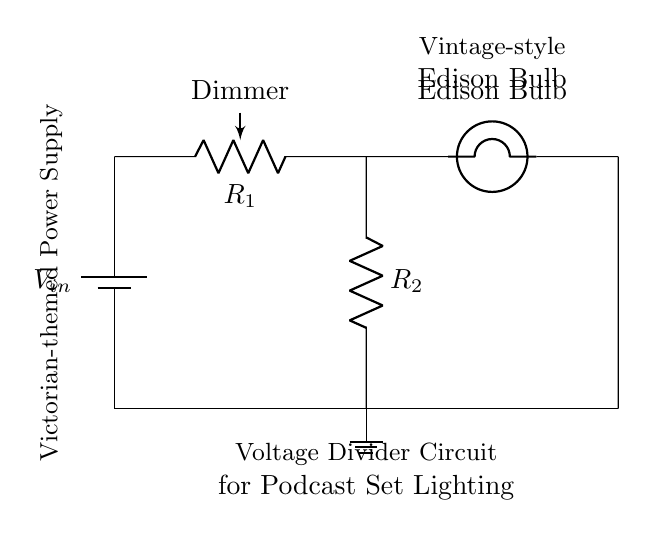What is the input voltage of the circuit? The circuit diagram shows a battery labeled as V_in, which indicates the input voltage. Therefore, we can refer to this label as the input voltage of the circuit.
Answer: V_in What types of components are used in this circuit? The circuit contains a battery, a potentiometer, a resistor, and a bulb. These components are standard in electronic circuits and can be identified directly from the labels in the diagram.
Answer: Battery, potentiometer, resistor, bulb How many resistors are present in the circuit? The circuit displays a potentiometer labeled R_1 and a separate resistor labeled R_2. Counting both components indicates that there are two resistors in total.
Answer: 2 What is the purpose of the potentiometer in this circuit? The potentiometer acts as a dimmer, allowing users to adjust the resistance, and thus the dimness of the Edison bulb's light output. This function is crucial for controlling the brightness of the vintage-style bulbs in the circuit.
Answer: Dimming What happens to the brightness of the bulb when the resistance in the circuit is increased? Increasing the resistance, particularly with the potentiometer, results in a decrease in current flowing through the bulb. Since less current equates to lower brightness, the Edison bulb will dim as resistance increases.
Answer: Dims Is this circuit suitable for high power appliances? This circuit is designed as a voltage divider, which is typically used for low power applications, such as dimming lights or powering small devices. The components shown are not rated for high power operations, confirming their low power usage.
Answer: No How does the voltage divider affect the Edison bulb? The voltage divider formed by R_1 and R_2 splits the input voltage. This reduced voltage is applied to the bulb, thereby controlling its brightness. The division of voltage effectively regulates how much power the bulb receives for illumination.
Answer: Controls brightness 